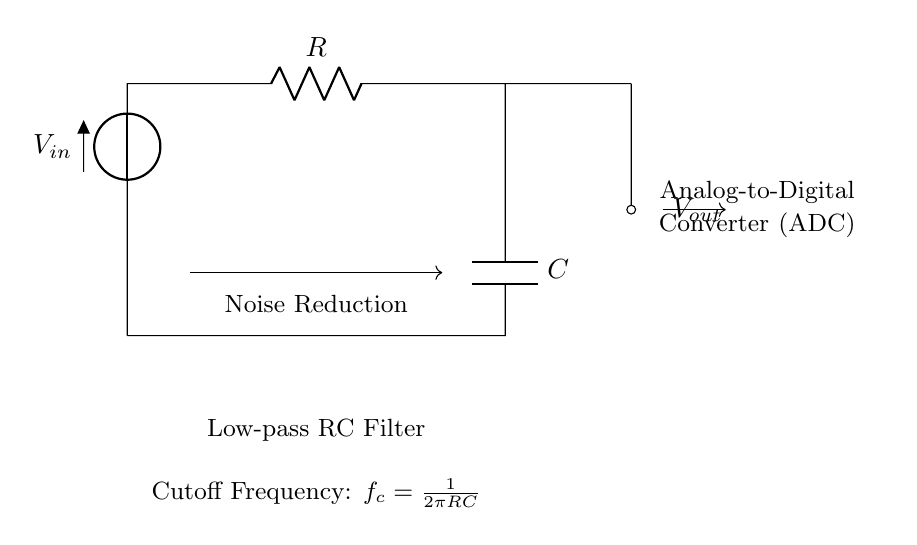What is the input voltage in this circuit? The input voltage is denoted as V_in, which is the voltage source connected at the top left corner of the circuit diagram.
Answer: V_in What component is used for noise reduction? The component utilized for noise reduction is the capacitor, represented by C in the diagram.
Answer: C What is the function of resistor R in this circuit? The resistor, labeled R, plays a role in setting the time constant when combined with the capacitor, directly affecting the filtering characteristics of the circuit.
Answer: Set time constant What is the cutoff frequency formula for this circuit? The cutoff frequency is given by the formula f_c = 1/(2πRC), which shows the relationship between the resistor, capacitor, and frequency response of the filter.
Answer: 1/(2πRC) What type of filter is represented here? The circuit is designed as a low-pass filter, which allows signals with a frequency lower than the cutoff frequency to pass through while attenuating higher frequencies.
Answer: Low-pass What happens to high-frequency signals in this circuit? High-frequency signals are attenuated or reduced in amplitude as they pass through the low-pass RC filter, due to the frequency-dependent response of the capacitor and resistor.
Answer: Attenuated What does V_out represent in this circuit? V_out signifies the output voltage, which is the filtered voltage measured across the capacitor in the circuit, after noise reduction has occurred.
Answer: V_out 